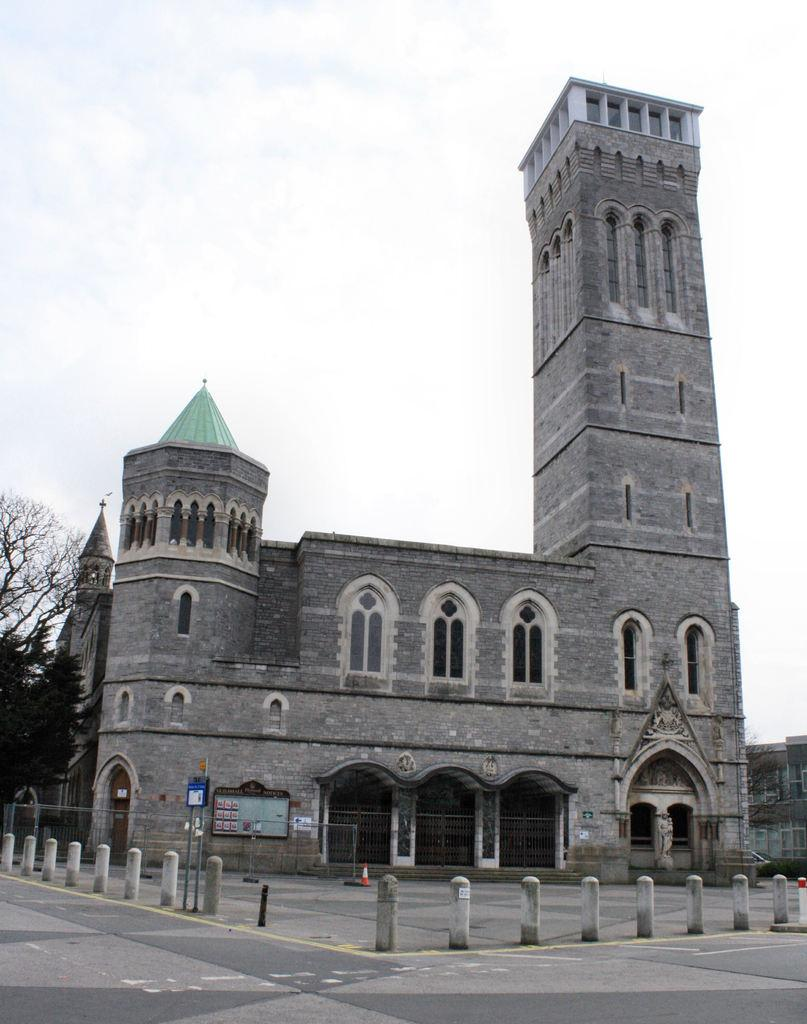What type of structures can be seen in the image? There are buildings in the image. What feature can be found on the buildings? There are windows in the image. What type of barrier is present in the image? There is fencing in the image. What type of vegetation is visible in the image? There are trees in the image. What vertical structures can be seen in the image? There are poles in the image. What flat, rectangular objects are present in the image? There are boards in the image. What part of the natural environment is visible in the image? The sky is visible in the image. What type of shock can be seen in the image? There is no shock present in the image. What type of window is visible in the image? The question is misleading, as the image contains windows on the buildings, not a single "window" object. 